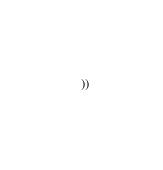Convert code to text. <code><loc_0><loc_0><loc_500><loc_500><_Lisp_>  ))

</code> 